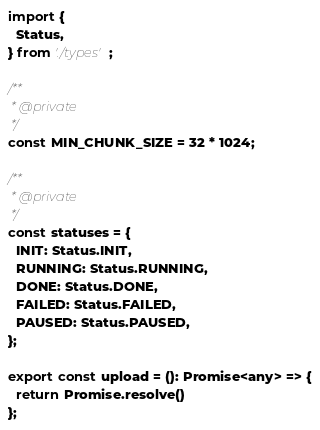<code> <loc_0><loc_0><loc_500><loc_500><_TypeScript_>import {
  Status,
} from './types';

/**
 * @private
 */
const MIN_CHUNK_SIZE = 32 * 1024;

/**
 * @private
 */
const statuses = {
  INIT: Status.INIT,
  RUNNING: Status.RUNNING,
  DONE: Status.DONE,
  FAILED: Status.FAILED,
  PAUSED: Status.PAUSED,
};

export const upload = (): Promise<any> => {
  return Promise.resolve()
};
</code> 